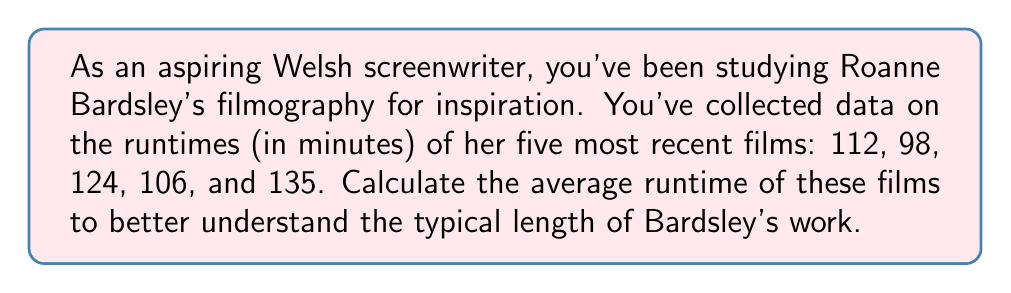Give your solution to this math problem. To calculate the average runtime of Roanne Bardsley's films, we need to follow these steps:

1. Sum up all the runtimes:
   $$112 + 98 + 124 + 106 + 135 = 575$$

2. Count the total number of films:
   There are 5 films in this dataset.

3. Calculate the average by dividing the sum by the number of films:
   $$\text{Average} = \frac{\text{Sum of runtimes}}{\text{Number of films}}$$
   $$\text{Average} = \frac{575}{5}$$
   $$\text{Average} = 115$$

Therefore, the average runtime of Roanne Bardsley's five most recent films is 115 minutes.
Answer: $115$ minutes 